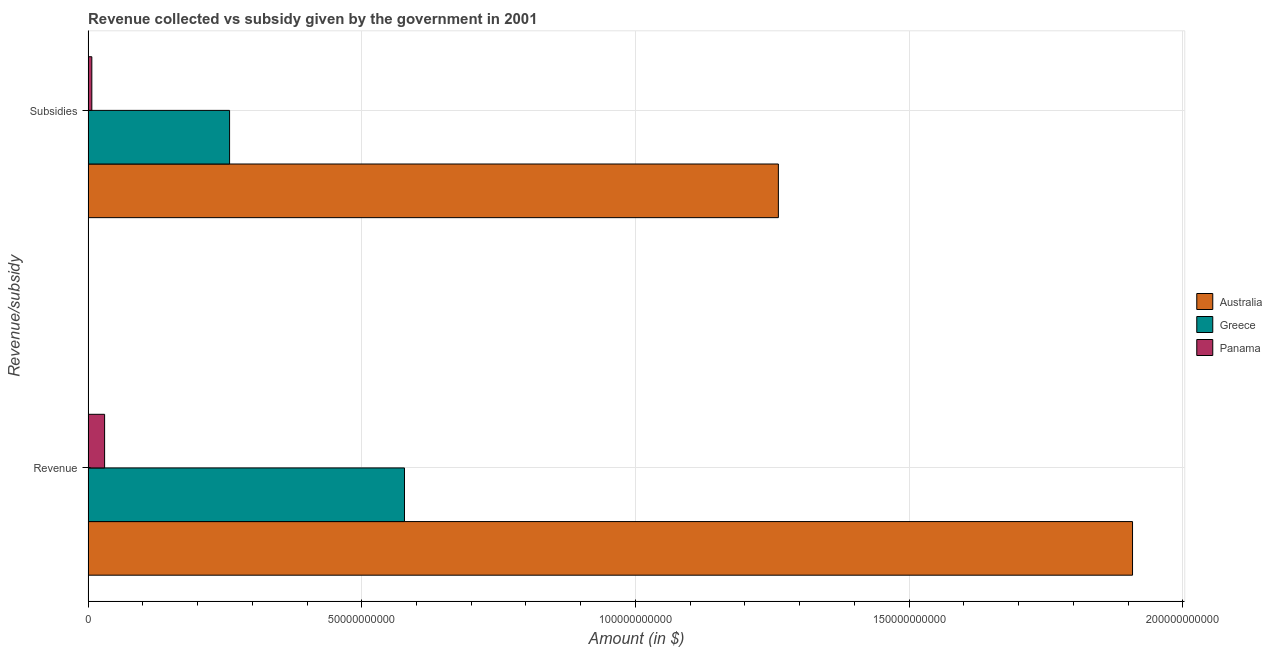How many different coloured bars are there?
Keep it short and to the point. 3. Are the number of bars on each tick of the Y-axis equal?
Provide a short and direct response. Yes. How many bars are there on the 2nd tick from the top?
Your answer should be very brief. 3. How many bars are there on the 2nd tick from the bottom?
Your response must be concise. 3. What is the label of the 2nd group of bars from the top?
Your answer should be compact. Revenue. What is the amount of revenue collected in Panama?
Offer a very short reply. 3.02e+09. Across all countries, what is the maximum amount of subsidies given?
Provide a short and direct response. 1.26e+11. Across all countries, what is the minimum amount of revenue collected?
Provide a succinct answer. 3.02e+09. In which country was the amount of revenue collected minimum?
Your response must be concise. Panama. What is the total amount of revenue collected in the graph?
Provide a succinct answer. 2.52e+11. What is the difference between the amount of subsidies given in Panama and that in Australia?
Your answer should be very brief. -1.25e+11. What is the difference between the amount of revenue collected in Panama and the amount of subsidies given in Greece?
Your response must be concise. -2.28e+1. What is the average amount of revenue collected per country?
Give a very brief answer. 8.39e+1. What is the difference between the amount of subsidies given and amount of revenue collected in Australia?
Provide a succinct answer. -6.47e+1. What is the ratio of the amount of revenue collected in Australia to that in Panama?
Provide a succinct answer. 63.24. Is the amount of subsidies given in Panama less than that in Australia?
Offer a very short reply. Yes. In how many countries, is the amount of revenue collected greater than the average amount of revenue collected taken over all countries?
Your response must be concise. 1. What does the 1st bar from the top in Revenue represents?
Offer a terse response. Panama. What does the 3rd bar from the bottom in Subsidies represents?
Ensure brevity in your answer.  Panama. How many bars are there?
Provide a succinct answer. 6. Does the graph contain any zero values?
Offer a very short reply. No. Does the graph contain grids?
Provide a short and direct response. Yes. What is the title of the graph?
Your answer should be very brief. Revenue collected vs subsidy given by the government in 2001. What is the label or title of the X-axis?
Your response must be concise. Amount (in $). What is the label or title of the Y-axis?
Ensure brevity in your answer.  Revenue/subsidy. What is the Amount (in $) of Australia in Revenue?
Your answer should be compact. 1.91e+11. What is the Amount (in $) in Greece in Revenue?
Provide a short and direct response. 5.78e+1. What is the Amount (in $) in Panama in Revenue?
Your answer should be compact. 3.02e+09. What is the Amount (in $) in Australia in Subsidies?
Provide a succinct answer. 1.26e+11. What is the Amount (in $) of Greece in Subsidies?
Offer a terse response. 2.59e+1. What is the Amount (in $) of Panama in Subsidies?
Ensure brevity in your answer.  6.84e+08. Across all Revenue/subsidy, what is the maximum Amount (in $) of Australia?
Your answer should be compact. 1.91e+11. Across all Revenue/subsidy, what is the maximum Amount (in $) in Greece?
Offer a terse response. 5.78e+1. Across all Revenue/subsidy, what is the maximum Amount (in $) of Panama?
Provide a succinct answer. 3.02e+09. Across all Revenue/subsidy, what is the minimum Amount (in $) in Australia?
Your response must be concise. 1.26e+11. Across all Revenue/subsidy, what is the minimum Amount (in $) in Greece?
Offer a terse response. 2.59e+1. Across all Revenue/subsidy, what is the minimum Amount (in $) in Panama?
Your response must be concise. 6.84e+08. What is the total Amount (in $) in Australia in the graph?
Provide a succinct answer. 3.17e+11. What is the total Amount (in $) in Greece in the graph?
Ensure brevity in your answer.  8.37e+1. What is the total Amount (in $) in Panama in the graph?
Provide a short and direct response. 3.70e+09. What is the difference between the Amount (in $) in Australia in Revenue and that in Subsidies?
Your answer should be very brief. 6.47e+1. What is the difference between the Amount (in $) of Greece in Revenue and that in Subsidies?
Provide a short and direct response. 3.20e+1. What is the difference between the Amount (in $) of Panama in Revenue and that in Subsidies?
Your answer should be compact. 2.33e+09. What is the difference between the Amount (in $) of Australia in Revenue and the Amount (in $) of Greece in Subsidies?
Offer a terse response. 1.65e+11. What is the difference between the Amount (in $) in Australia in Revenue and the Amount (in $) in Panama in Subsidies?
Offer a very short reply. 1.90e+11. What is the difference between the Amount (in $) in Greece in Revenue and the Amount (in $) in Panama in Subsidies?
Make the answer very short. 5.71e+1. What is the average Amount (in $) of Australia per Revenue/subsidy?
Give a very brief answer. 1.58e+11. What is the average Amount (in $) in Greece per Revenue/subsidy?
Your response must be concise. 4.18e+1. What is the average Amount (in $) in Panama per Revenue/subsidy?
Your response must be concise. 1.85e+09. What is the difference between the Amount (in $) of Australia and Amount (in $) of Greece in Revenue?
Give a very brief answer. 1.33e+11. What is the difference between the Amount (in $) of Australia and Amount (in $) of Panama in Revenue?
Your response must be concise. 1.88e+11. What is the difference between the Amount (in $) of Greece and Amount (in $) of Panama in Revenue?
Provide a succinct answer. 5.48e+1. What is the difference between the Amount (in $) of Australia and Amount (in $) of Greece in Subsidies?
Give a very brief answer. 1.00e+11. What is the difference between the Amount (in $) of Australia and Amount (in $) of Panama in Subsidies?
Your answer should be compact. 1.25e+11. What is the difference between the Amount (in $) in Greece and Amount (in $) in Panama in Subsidies?
Make the answer very short. 2.52e+1. What is the ratio of the Amount (in $) in Australia in Revenue to that in Subsidies?
Give a very brief answer. 1.51. What is the ratio of the Amount (in $) in Greece in Revenue to that in Subsidies?
Offer a very short reply. 2.24. What is the ratio of the Amount (in $) of Panama in Revenue to that in Subsidies?
Make the answer very short. 4.41. What is the difference between the highest and the second highest Amount (in $) in Australia?
Provide a short and direct response. 6.47e+1. What is the difference between the highest and the second highest Amount (in $) of Greece?
Make the answer very short. 3.20e+1. What is the difference between the highest and the second highest Amount (in $) in Panama?
Your response must be concise. 2.33e+09. What is the difference between the highest and the lowest Amount (in $) of Australia?
Your response must be concise. 6.47e+1. What is the difference between the highest and the lowest Amount (in $) of Greece?
Your response must be concise. 3.20e+1. What is the difference between the highest and the lowest Amount (in $) in Panama?
Your answer should be compact. 2.33e+09. 